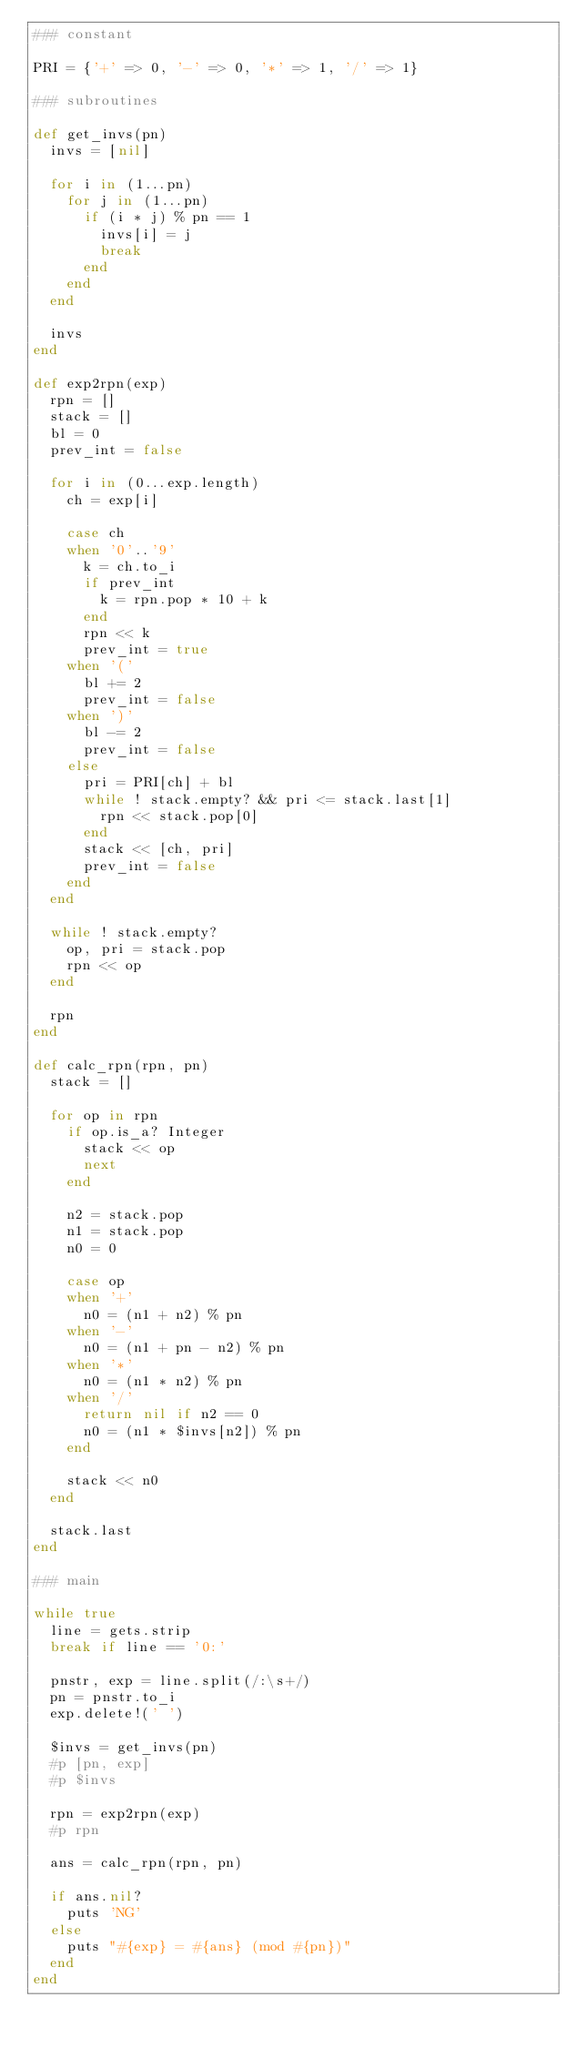Convert code to text. <code><loc_0><loc_0><loc_500><loc_500><_Ruby_>### constant

PRI = {'+' => 0, '-' => 0, '*' => 1, '/' => 1}

### subroutines

def get_invs(pn)
  invs = [nil]

  for i in (1...pn)
    for j in (1...pn)
      if (i * j) % pn == 1
        invs[i] = j
        break
      end
    end
  end

  invs
end

def exp2rpn(exp)
  rpn = []
  stack = []
  bl = 0
  prev_int = false

  for i in (0...exp.length)
    ch = exp[i]

    case ch
    when '0'..'9'
      k = ch.to_i
      if prev_int
        k = rpn.pop * 10 + k
      end
      rpn << k
      prev_int = true
    when '('
      bl += 2
      prev_int = false
    when ')'
      bl -= 2
      prev_int = false
    else
      pri = PRI[ch] + bl
      while ! stack.empty? && pri <= stack.last[1]
        rpn << stack.pop[0]
      end
      stack << [ch, pri]
      prev_int = false
    end
  end

  while ! stack.empty?
    op, pri = stack.pop
    rpn << op
  end

  rpn
end

def calc_rpn(rpn, pn)
  stack = []

  for op in rpn
    if op.is_a? Integer
      stack << op
      next
    end

    n2 = stack.pop
    n1 = stack.pop
    n0 = 0

    case op
    when '+'
      n0 = (n1 + n2) % pn
    when '-'
      n0 = (n1 + pn - n2) % pn
    when '*'
      n0 = (n1 * n2) % pn
    when '/'
      return nil if n2 == 0
      n0 = (n1 * $invs[n2]) % pn
    end

    stack << n0
  end

  stack.last
end

### main

while true
  line = gets.strip
  break if line == '0:'

  pnstr, exp = line.split(/:\s+/)
  pn = pnstr.to_i
  exp.delete!(' ')

  $invs = get_invs(pn)
  #p [pn, exp]
  #p $invs

  rpn = exp2rpn(exp)
  #p rpn

  ans = calc_rpn(rpn, pn)

  if ans.nil?
    puts 'NG'
  else
    puts "#{exp} = #{ans} (mod #{pn})"
  end
end</code> 